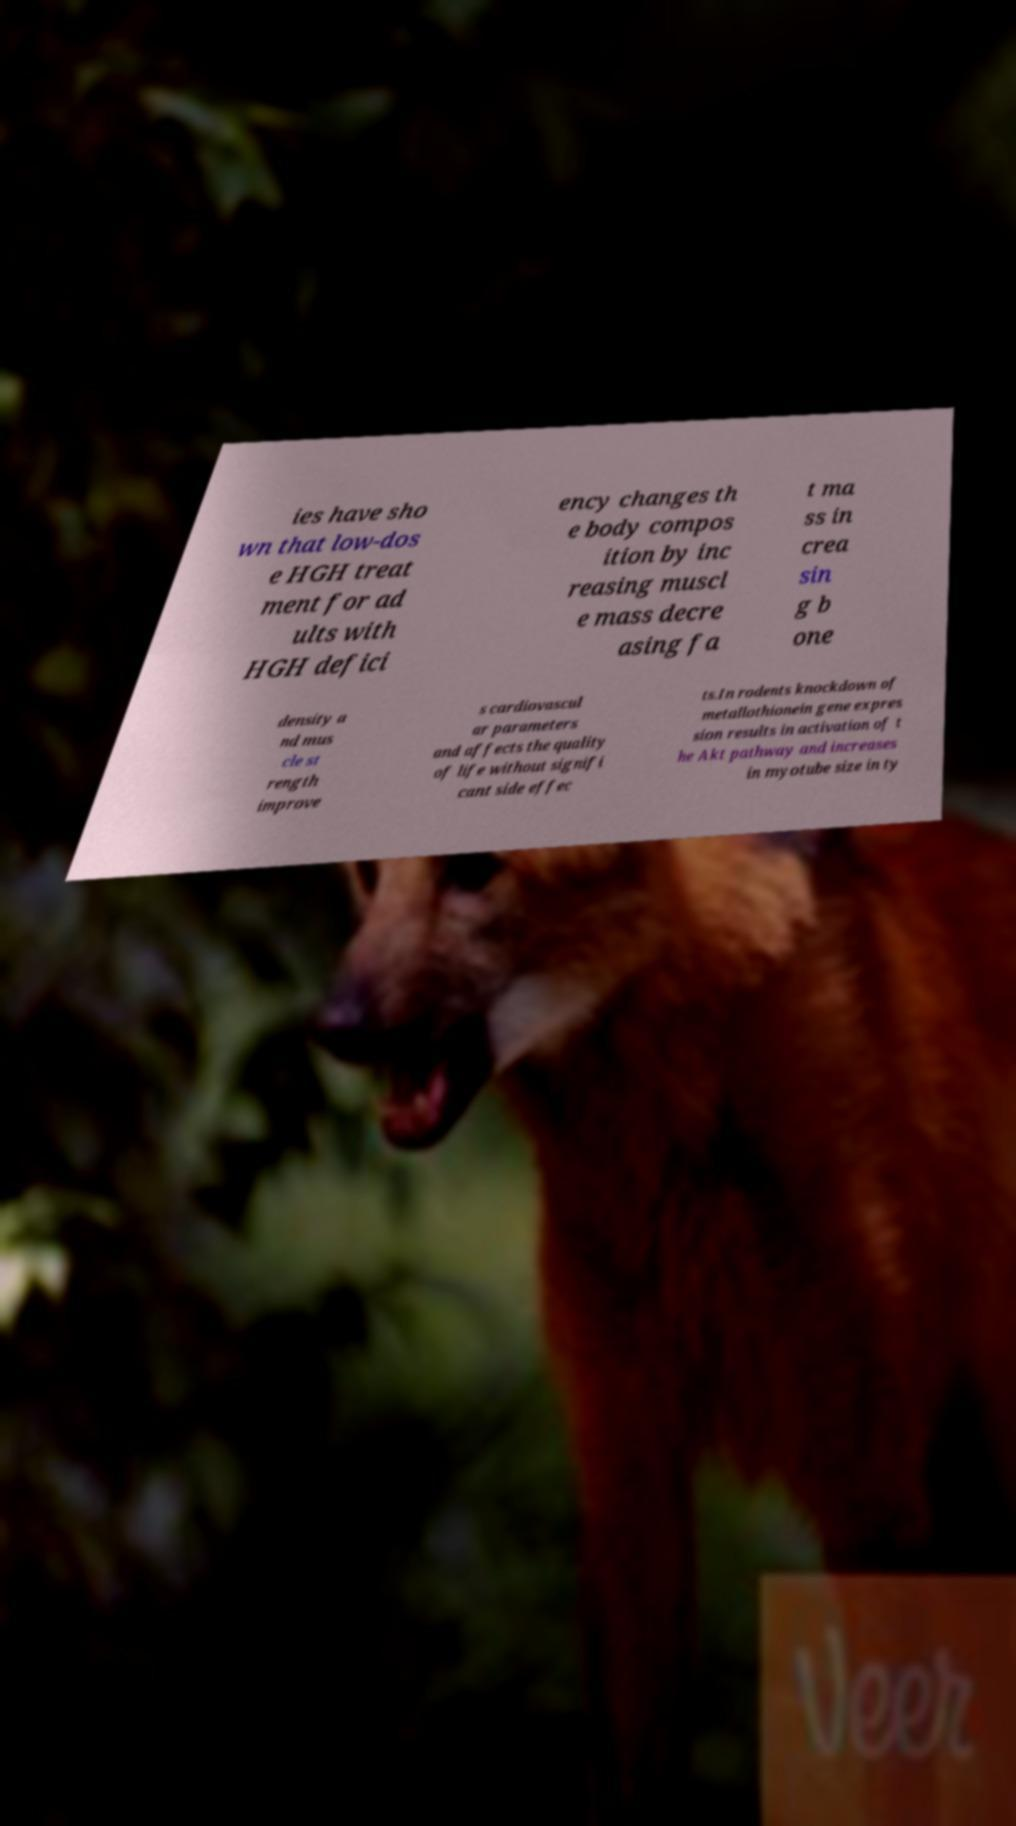Could you extract and type out the text from this image? ies have sho wn that low-dos e HGH treat ment for ad ults with HGH defici ency changes th e body compos ition by inc reasing muscl e mass decre asing fa t ma ss in crea sin g b one density a nd mus cle st rength improve s cardiovascul ar parameters and affects the quality of life without signifi cant side effec ts.In rodents knockdown of metallothionein gene expres sion results in activation of t he Akt pathway and increases in myotube size in ty 